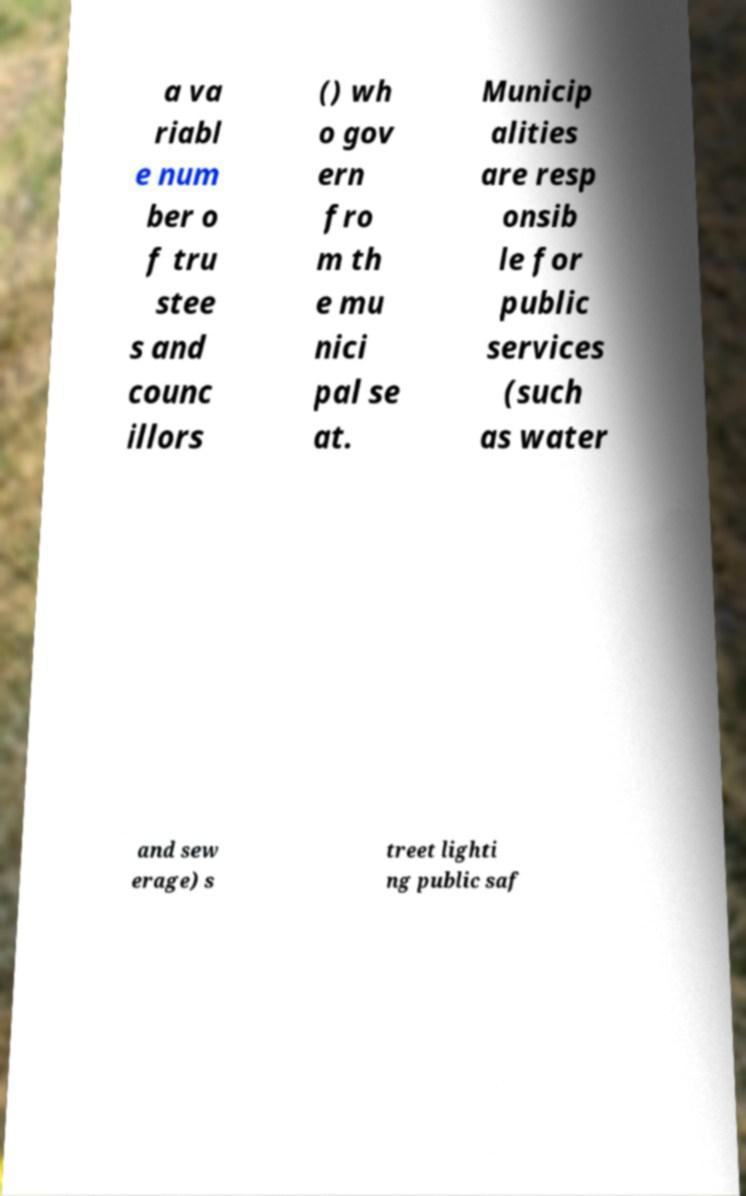Could you extract and type out the text from this image? a va riabl e num ber o f tru stee s and counc illors () wh o gov ern fro m th e mu nici pal se at. Municip alities are resp onsib le for public services (such as water and sew erage) s treet lighti ng public saf 